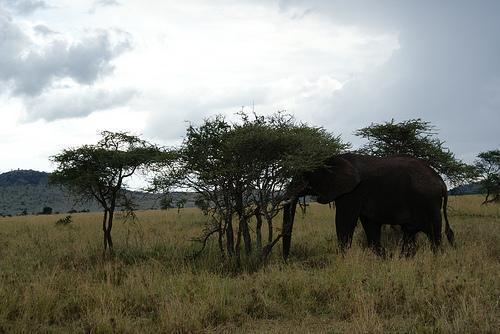How many elephants appear to be here?
Give a very brief answer. 1. How many elephants?
Give a very brief answer. 1. How many elephants are in the photo?
Give a very brief answer. 1. 